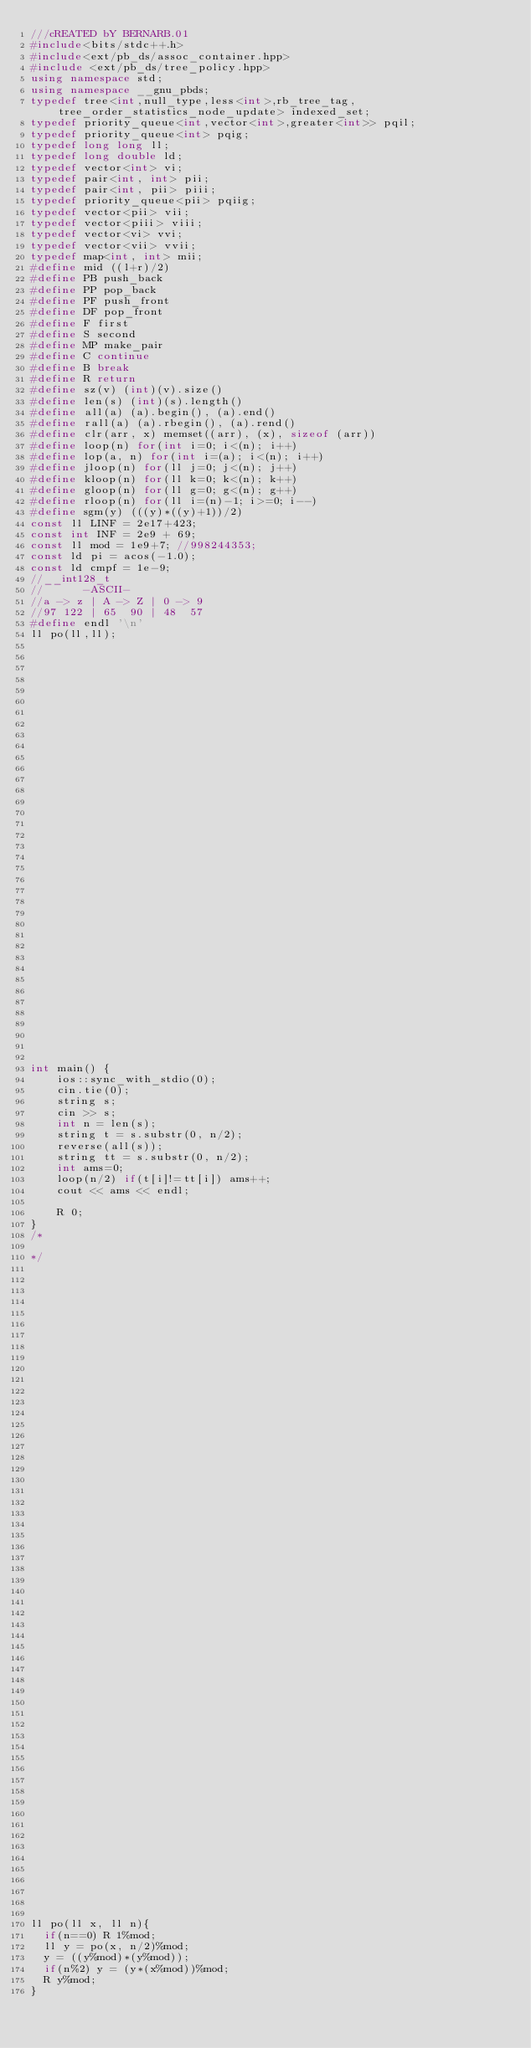<code> <loc_0><loc_0><loc_500><loc_500><_C++_>///cREATED bY BERNARB.01
#include<bits/stdc++.h>
#include<ext/pb_ds/assoc_container.hpp>
#include <ext/pb_ds/tree_policy.hpp>
using namespace std;
using namespace __gnu_pbds;
typedef tree<int,null_type,less<int>,rb_tree_tag, tree_order_statistics_node_update> indexed_set;
typedef priority_queue<int,vector<int>,greater<int>> pqil;
typedef priority_queue<int> pqig;
typedef long long ll;
typedef long double ld;
typedef vector<int> vi;
typedef pair<int, int> pii;
typedef pair<int, pii> piii;
typedef priority_queue<pii> pqiig;
typedef vector<pii> vii;
typedef vector<piii> viii;
typedef vector<vi> vvi;
typedef vector<vii> vvii;
typedef map<int, int> mii;
#define mid ((l+r)/2)
#define PB push_back
#define PP pop_back
#define PF push_front
#define DF pop_front
#define F first
#define S second
#define MP make_pair
#define C continue
#define B break
#define R return
#define sz(v) (int)(v).size()
#define len(s) (int)(s).length()
#define all(a) (a).begin(), (a).end()
#define rall(a) (a).rbegin(), (a).rend()
#define clr(arr, x) memset((arr), (x), sizeof (arr))
#define loop(n) for(int i=0; i<(n); i++)
#define lop(a, n) for(int i=(a); i<(n); i++)
#define jloop(n) for(ll j=0; j<(n); j++)
#define kloop(n) for(ll k=0; k<(n); k++)
#define gloop(n) for(ll g=0; g<(n); g++)
#define rloop(n) for(ll i=(n)-1; i>=0; i--)
#define sgm(y) (((y)*((y)+1))/2)
const ll LINF = 2e17+423;
const int INF = 2e9 + 69;
const ll mod = 1e9+7; //998244353;
const ld pi = acos(-1.0);
const ld cmpf = 1e-9;
//__int128_t
//      -ASCII-
//a -> z | A -> Z | 0 -> 9
//97 122 | 65  90 | 48  57
#define endl '\n'
ll po(ll,ll);






































int main() {
    ios::sync_with_stdio(0);
    cin.tie(0);
    string s;
    cin >> s;
    int n = len(s);
    string t = s.substr(0, n/2);
    reverse(all(s));
    string tt = s.substr(0, n/2);
    int ams=0;
    loop(n/2) if(t[i]!=tt[i]) ams++;
    cout << ams << endl;

    R 0;
}
/*

*/



























































ll po(ll x, ll n){
  if(n==0) R 1%mod;
  ll y = po(x, n/2)%mod;
  y = ((y%mod)*(y%mod));
  if(n%2) y = (y*(x%mod))%mod;
  R y%mod;
}
</code> 